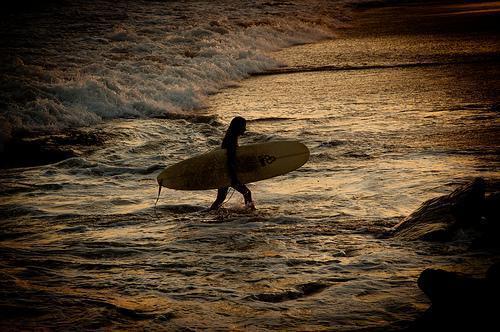How many people are in the photo?
Give a very brief answer. 1. How many surfboards are there?
Give a very brief answer. 1. How many people are shown?
Give a very brief answer. 1. 